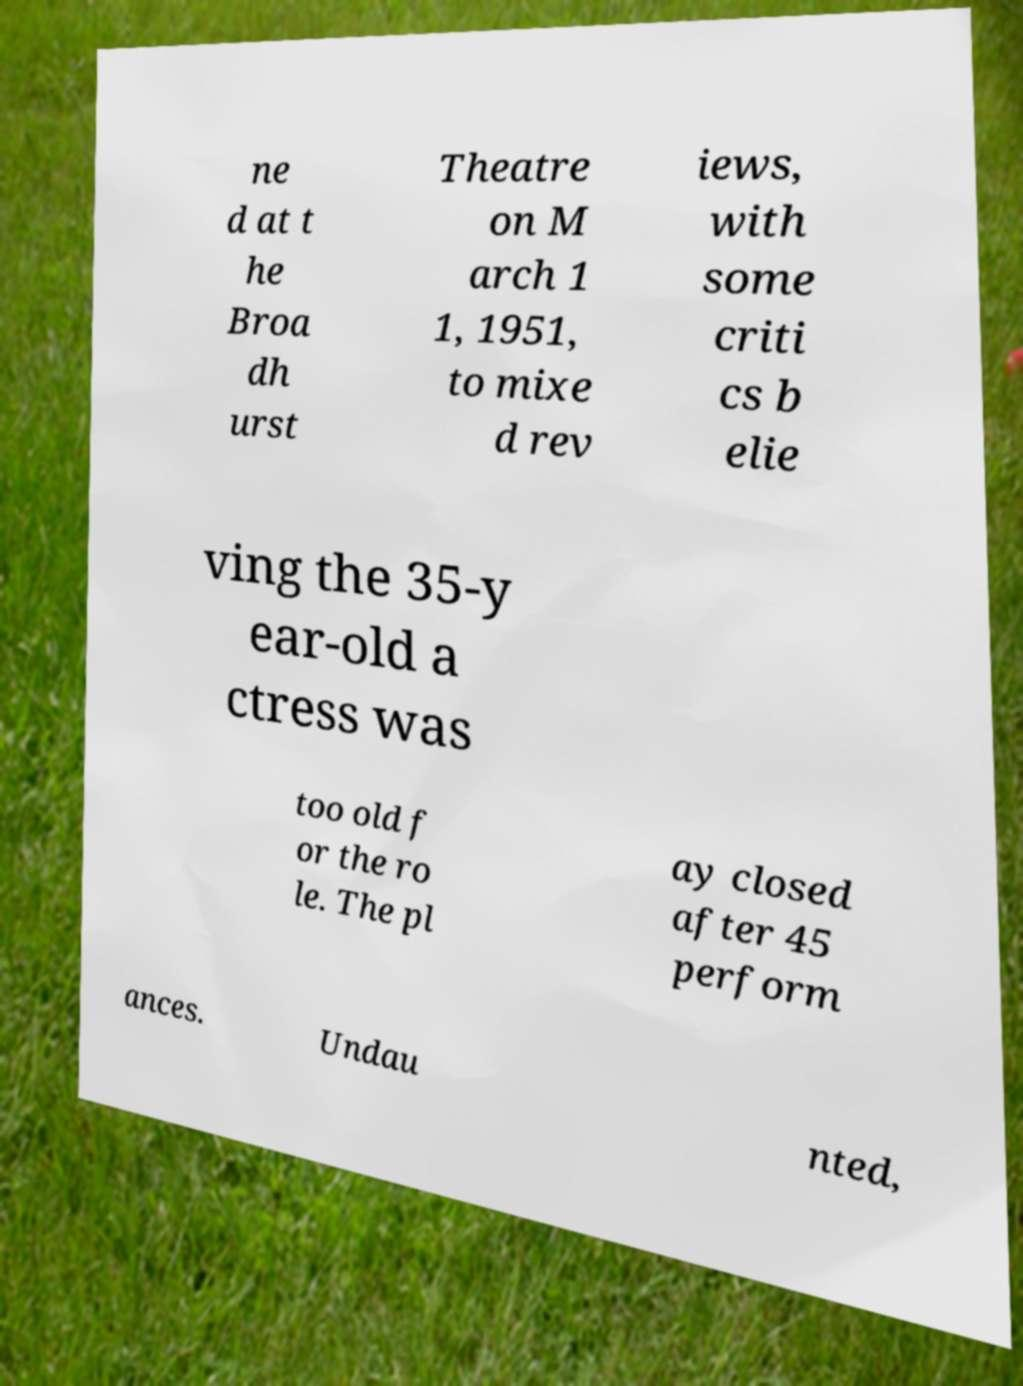What messages or text are displayed in this image? I need them in a readable, typed format. ne d at t he Broa dh urst Theatre on M arch 1 1, 1951, to mixe d rev iews, with some criti cs b elie ving the 35-y ear-old a ctress was too old f or the ro le. The pl ay closed after 45 perform ances. Undau nted, 